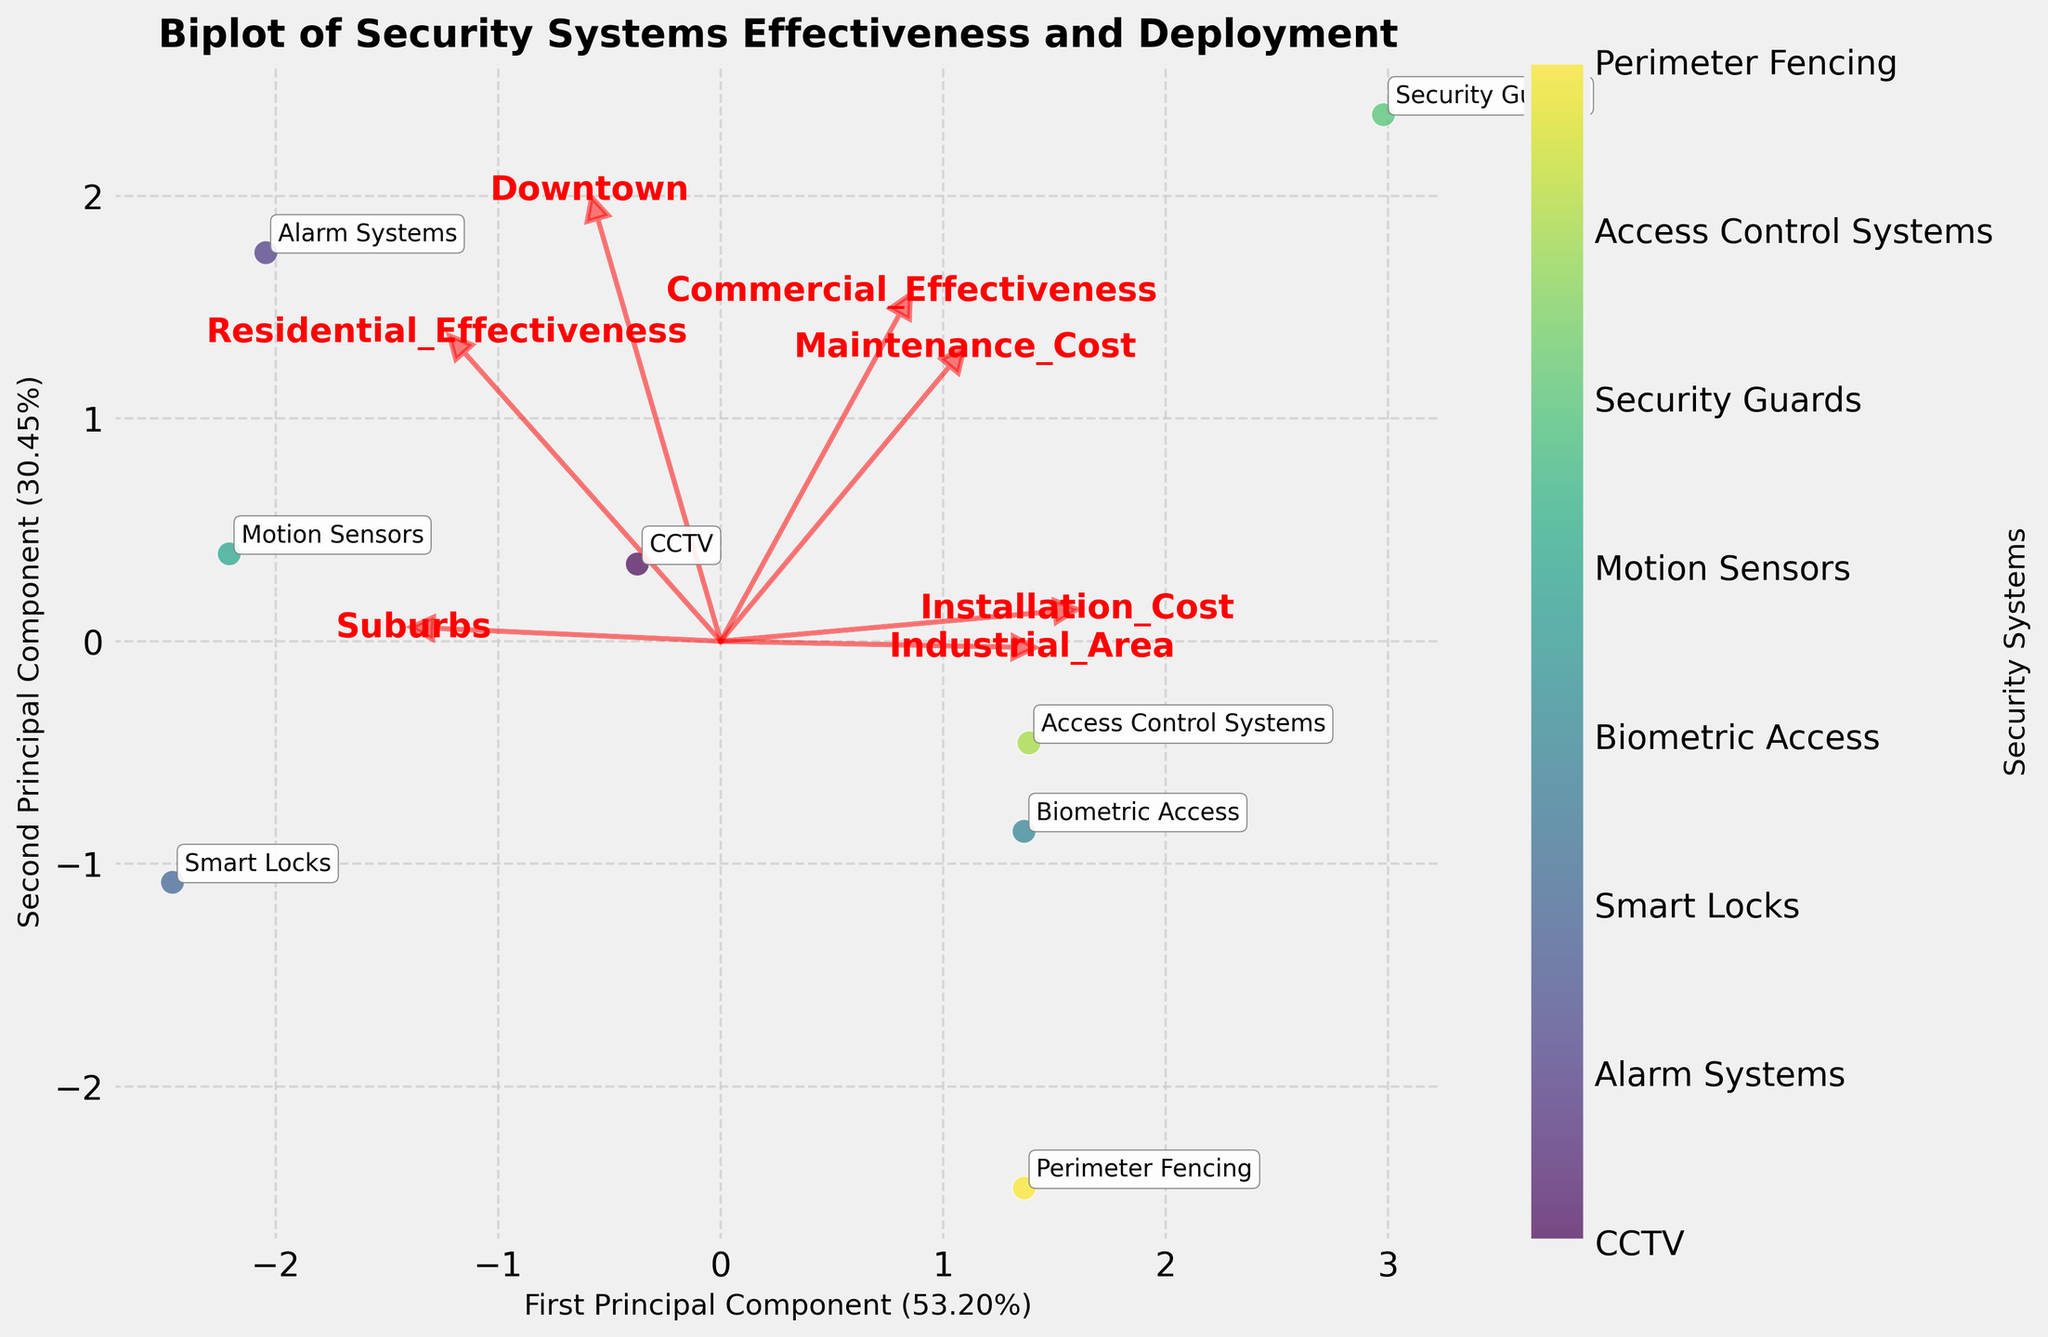What is the title of the figure? The title of the figure is displayed prominently at the top. It reads "Biplot of Security Systems Effectiveness and Deployment".
Answer: Biplot of Security Systems Effectiveness and Deployment Which security system is furthest to the left on the first principal component axis? To determine this, observe the positioning of security systems along the horizontal (first principal component) axis. The security system located the furthest to the left is Security Guards.
Answer: Security Guards What security systems are closest to each other on the plot? The proximity of points in the plot indicates their similarity in both principal components. Smart Locks and Motion Sensors appear to be the closest to each other.
Answer: Smart Locks and Motion Sensors Which feature vector appears to be the most relevant for explaining the first principal component? To identify this, observe the directions and lengths of the feature vectors. The vector for "Residential Effectiveness" extends significantly in the direction of the first principal component, indicating its high relevance.
Answer: Residential Effectiveness How are the features 'Installation Cost' and 'Maintenance Cost' oriented relative to each other? By examining the plot, you can see that the feature vectors for 'Installation Cost' and 'Maintenance Cost' are oriented relatively close to each other. This indicates a positive correlation between them.
Answer: Positively correlated Which security system shows a high score in 'Commercial Effectiveness' but low in 'Residential Effectiveness'? Look for the point annotated with a name near the vector for 'Commercial Effectiveness' and far from 'Residential Effectiveness'. 'Biometric Access' fits this description.
Answer: Biometric Access Which security system is most strongly associated with the 'Downtown' feature? To determine this, check which data point is closest to the direction of the 'Downtown' feature vector. 'Alarm Systems' appears to be the most strongly associated with 'Downtown'.
Answer: Alarm Systems What do the lengths of the feature vectors represent? The lengths of the feature vectors indicate the relative importance or contribution of those features to the principal components. Longer vectors have a greater contribution.
Answer: Importance/contribution to components Which area (Downtown, Suburbs, or Industrial Area) has a significant negative relationship with 'Smart Locks'? Observe the direction of the 'Smart Locks' data point relative to the feature vectors. 'Downtown' is oriented in the opposite direction, indicating a significant negative relationship.
Answer: Downtown Which security system has the highest combination of 'Residential Effectiveness' and 'Commercial Effectiveness'? The point that is farthest in the direction of both 'Residential Effectiveness' and 'Commercial Effectiveness' feature vectors would be the answer. 'Alarm Systems' shows the highest combination of both.
Answer: Alarm Systems 